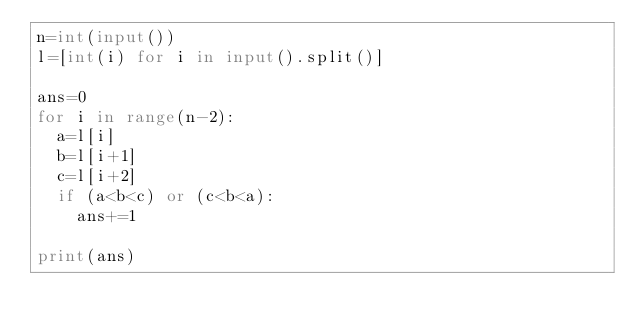<code> <loc_0><loc_0><loc_500><loc_500><_Python_>n=int(input())
l=[int(i) for i in input().split()]

ans=0
for i in range(n-2):
  a=l[i]
  b=l[i+1]
  c=l[i+2]
  if (a<b<c) or (c<b<a):
    ans+=1

print(ans)</code> 